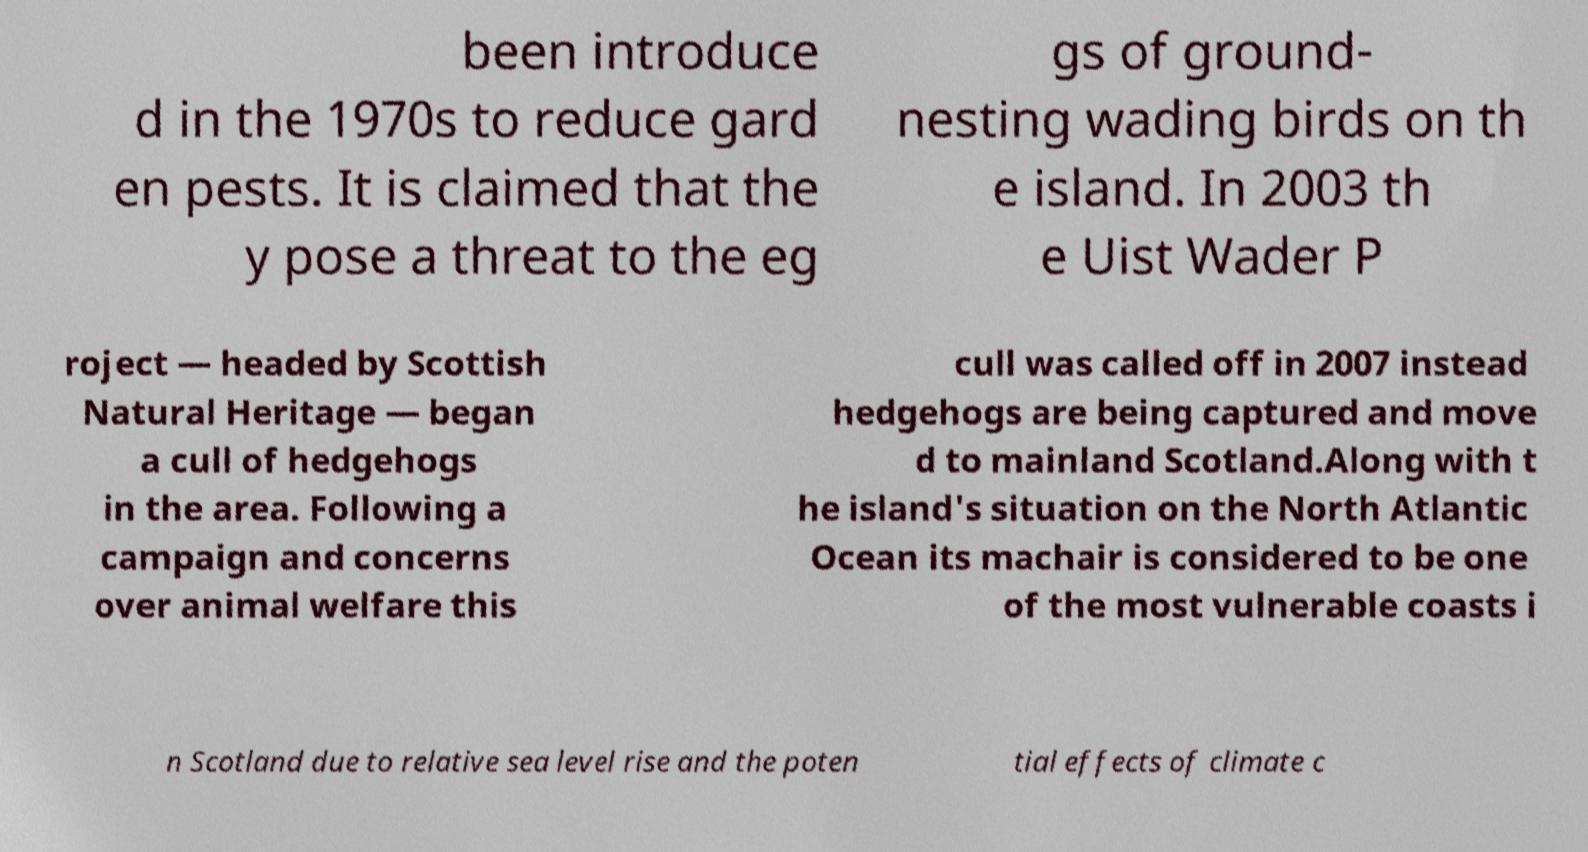Can you accurately transcribe the text from the provided image for me? been introduce d in the 1970s to reduce gard en pests. It is claimed that the y pose a threat to the eg gs of ground- nesting wading birds on th e island. In 2003 th e Uist Wader P roject — headed by Scottish Natural Heritage — began a cull of hedgehogs in the area. Following a campaign and concerns over animal welfare this cull was called off in 2007 instead hedgehogs are being captured and move d to mainland Scotland.Along with t he island's situation on the North Atlantic Ocean its machair is considered to be one of the most vulnerable coasts i n Scotland due to relative sea level rise and the poten tial effects of climate c 